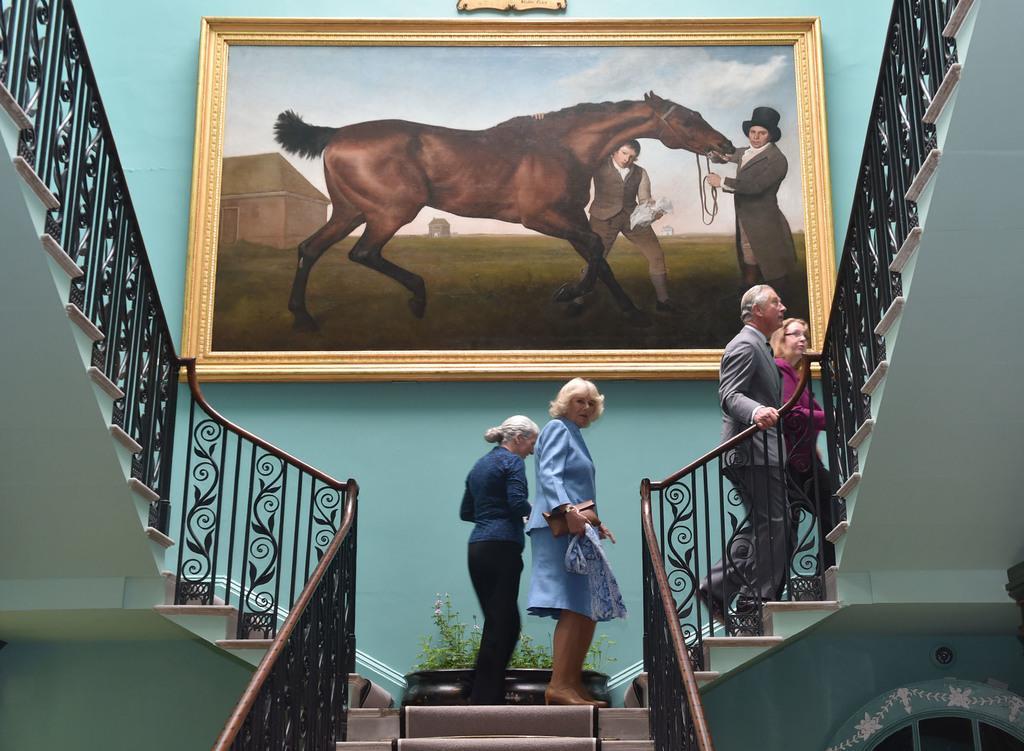In one or two sentences, can you explain what this image depicts? There is a staircase going to the left and right side. Four persons are walking on the staircase. On the staircase there is a big vessel with some plants. On the wall there is a painting. The painting consists of two people and a horse. And a person is holding the horse wearing a hat. And there are railings for the staircase. 